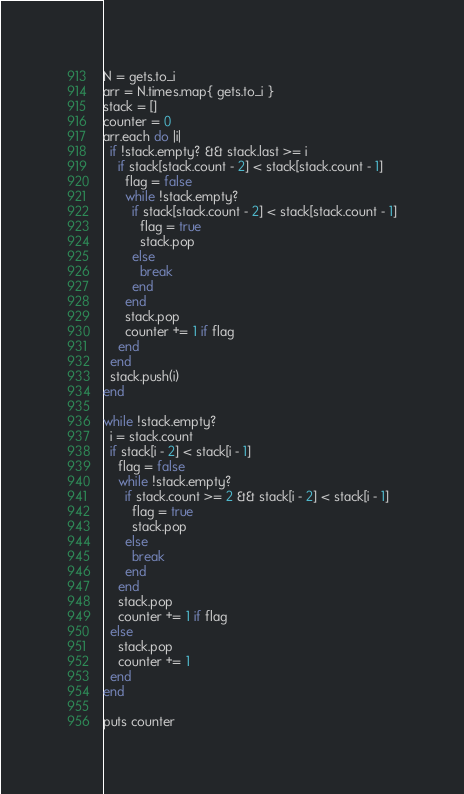Convert code to text. <code><loc_0><loc_0><loc_500><loc_500><_Ruby_>N = gets.to_i
arr = N.times.map{ gets.to_i }
stack = []
counter = 0
arr.each do |i|
  if !stack.empty? && stack.last >= i
    if stack[stack.count - 2] < stack[stack.count - 1]
      flag = false
      while !stack.empty?
        if stack[stack.count - 2] < stack[stack.count - 1]
          flag = true
          stack.pop
        else
          break
        end
      end
      stack.pop
      counter += 1 if flag
    end
  end
  stack.push(i)
end

while !stack.empty?
  i = stack.count
  if stack[i - 2] < stack[i - 1]
    flag = false
    while !stack.empty?
      if stack.count >= 2 && stack[i - 2] < stack[i - 1]
        flag = true
        stack.pop
      else
        break
      end
    end
    stack.pop
    counter += 1 if flag
  else
    stack.pop
    counter += 1
  end
end

puts counter</code> 